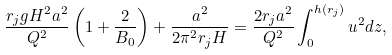Convert formula to latex. <formula><loc_0><loc_0><loc_500><loc_500>\frac { r _ { j } g H ^ { 2 } a ^ { 2 } } { Q ^ { 2 } } \left ( 1 + \frac { 2 } { B _ { 0 } } \right ) + \frac { a ^ { 2 } } { 2 \pi ^ { 2 } r _ { j } H } = \frac { 2 r _ { j } a ^ { 2 } } { Q ^ { 2 } } \int _ { 0 } ^ { h ( r _ { j } ) } u ^ { 2 } d z ,</formula> 